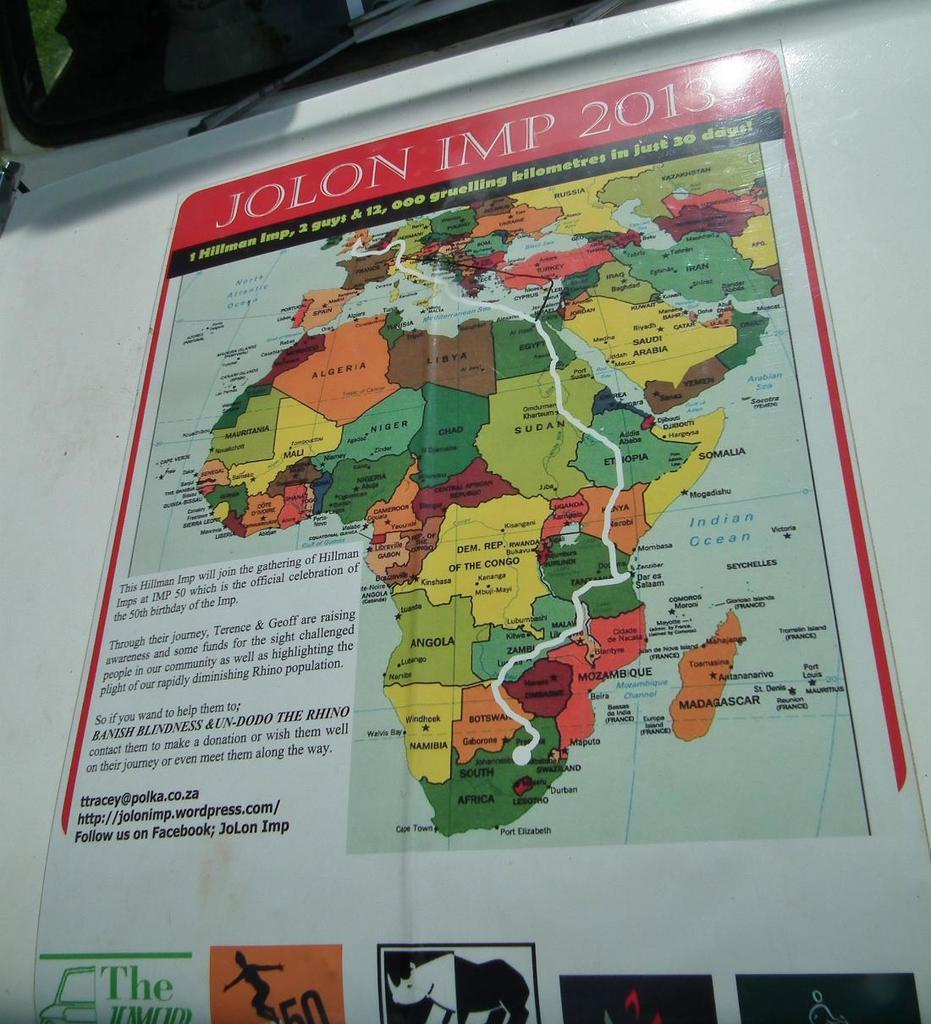<image>
Share a concise interpretation of the image provided. A map of Africa says Jolon IMP 2013 at the top. 